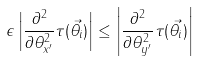Convert formula to latex. <formula><loc_0><loc_0><loc_500><loc_500>\epsilon \left | \frac { \partial ^ { 2 } } { \partial \theta _ { x ^ { \prime } } ^ { 2 } } \tau ( \vec { \theta _ { i } } ) \right | \leq \left | \frac { \partial ^ { 2 } } { \partial \theta _ { y ^ { \prime } } ^ { 2 } } \tau ( \vec { \theta _ { i } } ) \right |</formula> 